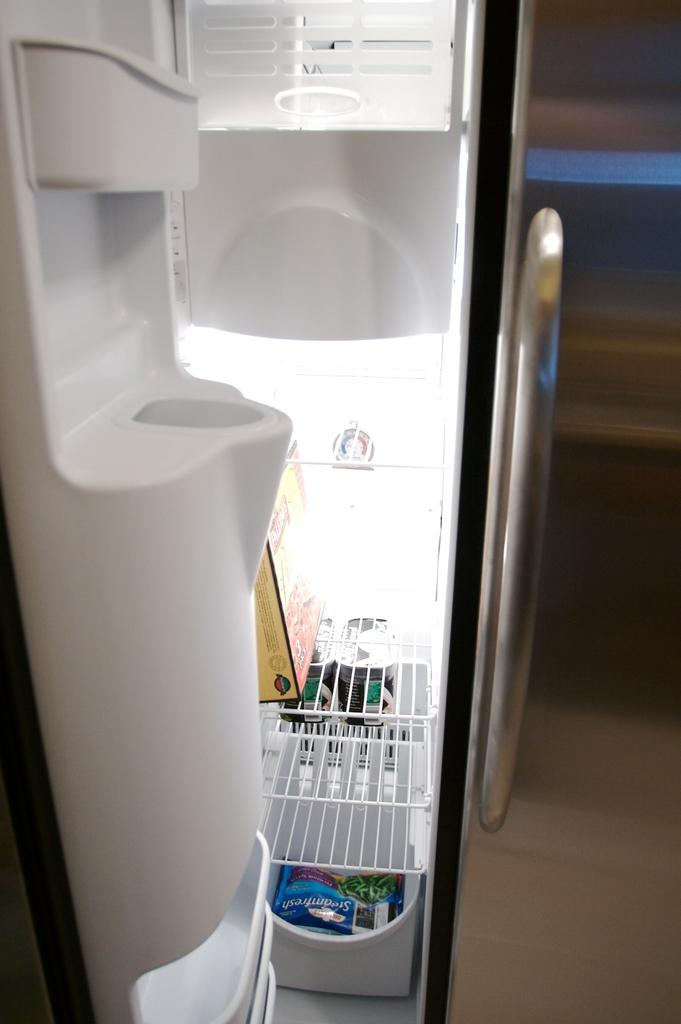<image>
Offer a succinct explanation of the picture presented. A white refrigerator with a bag of Steamfresh vegetables in the freezer section. 